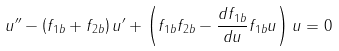Convert formula to latex. <formula><loc_0><loc_0><loc_500><loc_500>u ^ { \prime \prime } - \left ( f _ { 1 b } + f _ { 2 b } \right ) u ^ { \prime } + \left ( f _ { 1 b } f _ { 2 b } - \frac { d f _ { 1 b } } { d u } f _ { 1 b } u \right ) u = 0</formula> 